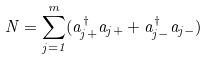Convert formula to latex. <formula><loc_0><loc_0><loc_500><loc_500>N = \sum _ { j = 1 } ^ { m } ( a _ { j + } ^ { \dagger } a _ { j + } + a _ { j - } ^ { \dagger } a _ { j - } )</formula> 